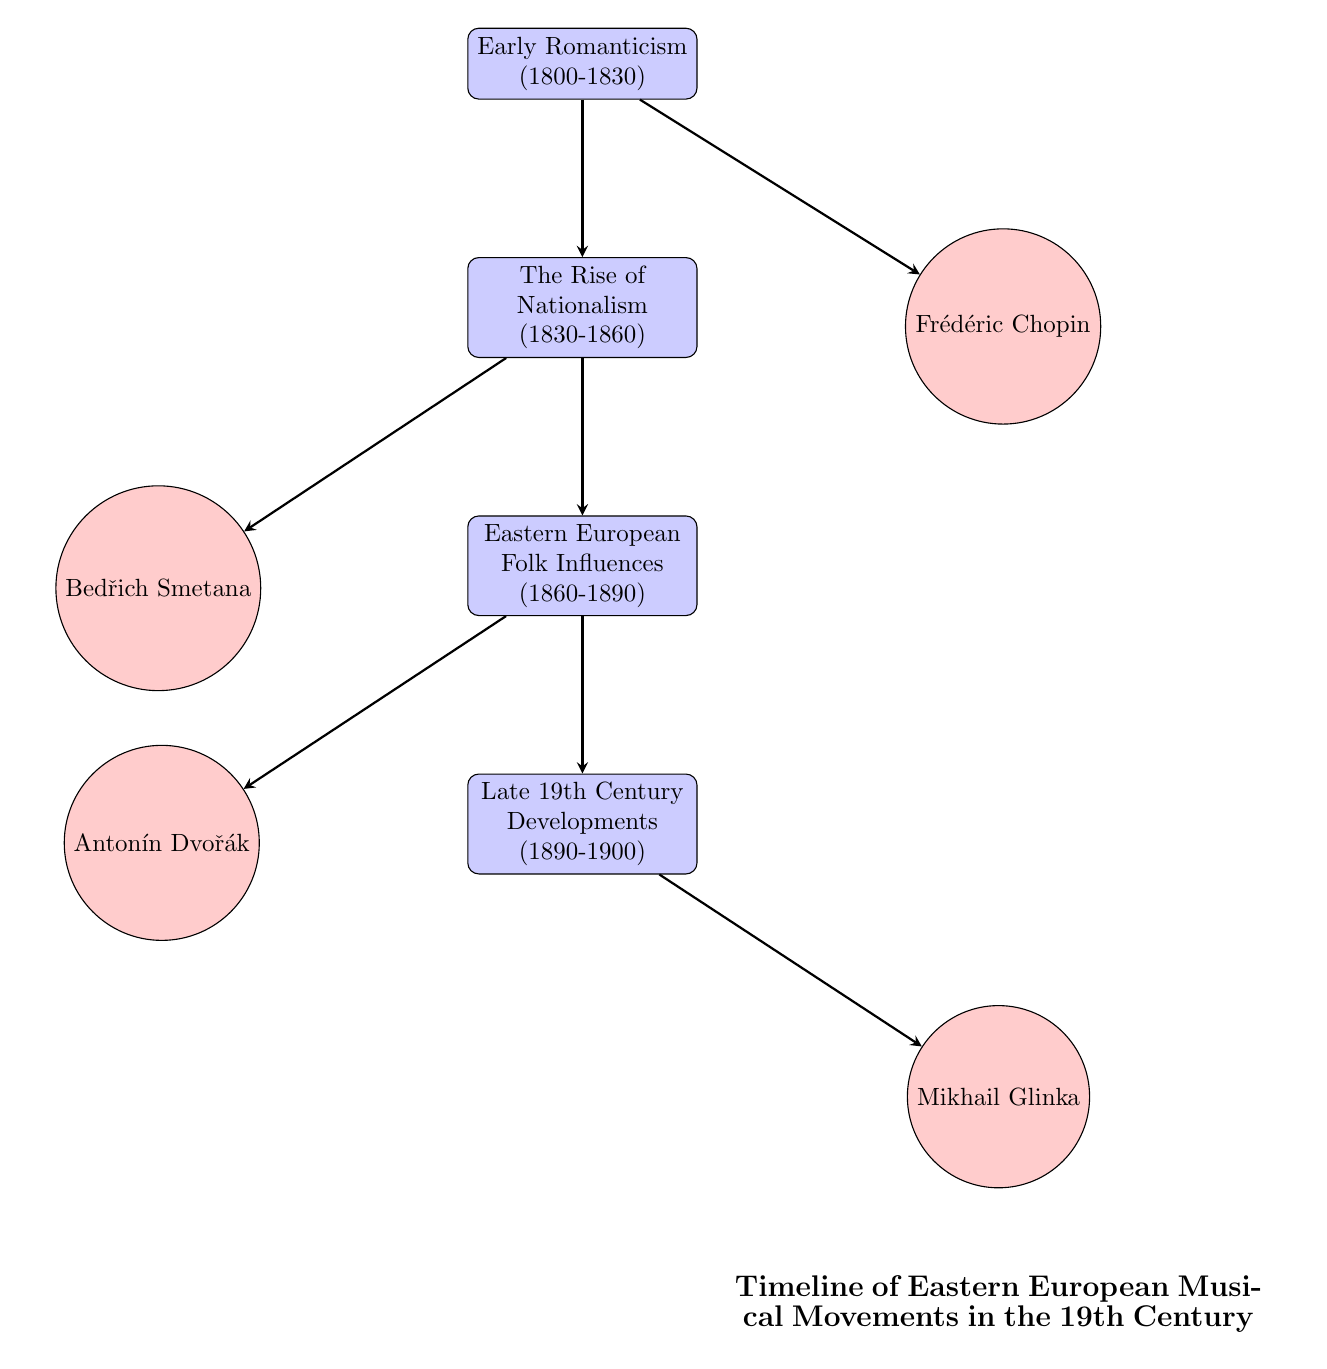What time period does Early Romanticism cover? The node labeled "Early Romanticism" states the years 1800-1830. Therefore, the time period it covers is specifically identified as such in the diagram.
Answer: 1800-1830 Which composer is associated with the national dance forms like Mazurkas? The diagram connects the node "Frédéric Chopin" with "Early Romanticism," and the details in the Chopin node specify that he incorporated Polish dance forms such as Mazurkas.
Answer: Frédéric Chopin How many nodes represent composers in this diagram? By counting the nodes specifically identified as composers (Frédéric Chopin, Bedřich Smetana, Antonín Dvořák, and Mikhail Glinka), we find there are four such nodes.
Answer: 4 What is the relationship between The Rise of Nationalism and Bedřich Smetana? The diagram shows a direct arrow connecting "The Rise of Nationalism" as a cause or influence to the node representing "Bedřich Smetana," indicating Smetana's contributions are influenced by the rise in nationalism.
Answer: Influence What musical movement directly follows Eastern European Folk Influences? By reviewing the flow in the diagram, the node "Late 19th Century Developments" is directly below "Eastern European Folk Influences," indicating that it follows it in the timeline.
Answer: Late 19th Century Developments Which composer is recognized as the father of Russian classical music? The node for "Mikhail Glinka" explicitly states that he is considered the father of Russian classical music according to the information provided in the diagram.
Answer: Mikhail Glinka What is the main characteristic of the period labeled Eastern European Folk Influences? This specific node describes the significant use of folk tunes and rhythms in classical compositions, thus defining the main characteristic of that period.
Answer: Use of folk tunes and rhythms Which event connects the 19th-century musical movements to the use of folk music in classical compositions? The arrow from "The Rise of Nationalism" to "Eastern European Folk Influences" links the motivation of nationalism to the incorporation of folk music, thereby directly connecting these concepts.
Answer: The Rise of Nationalism 